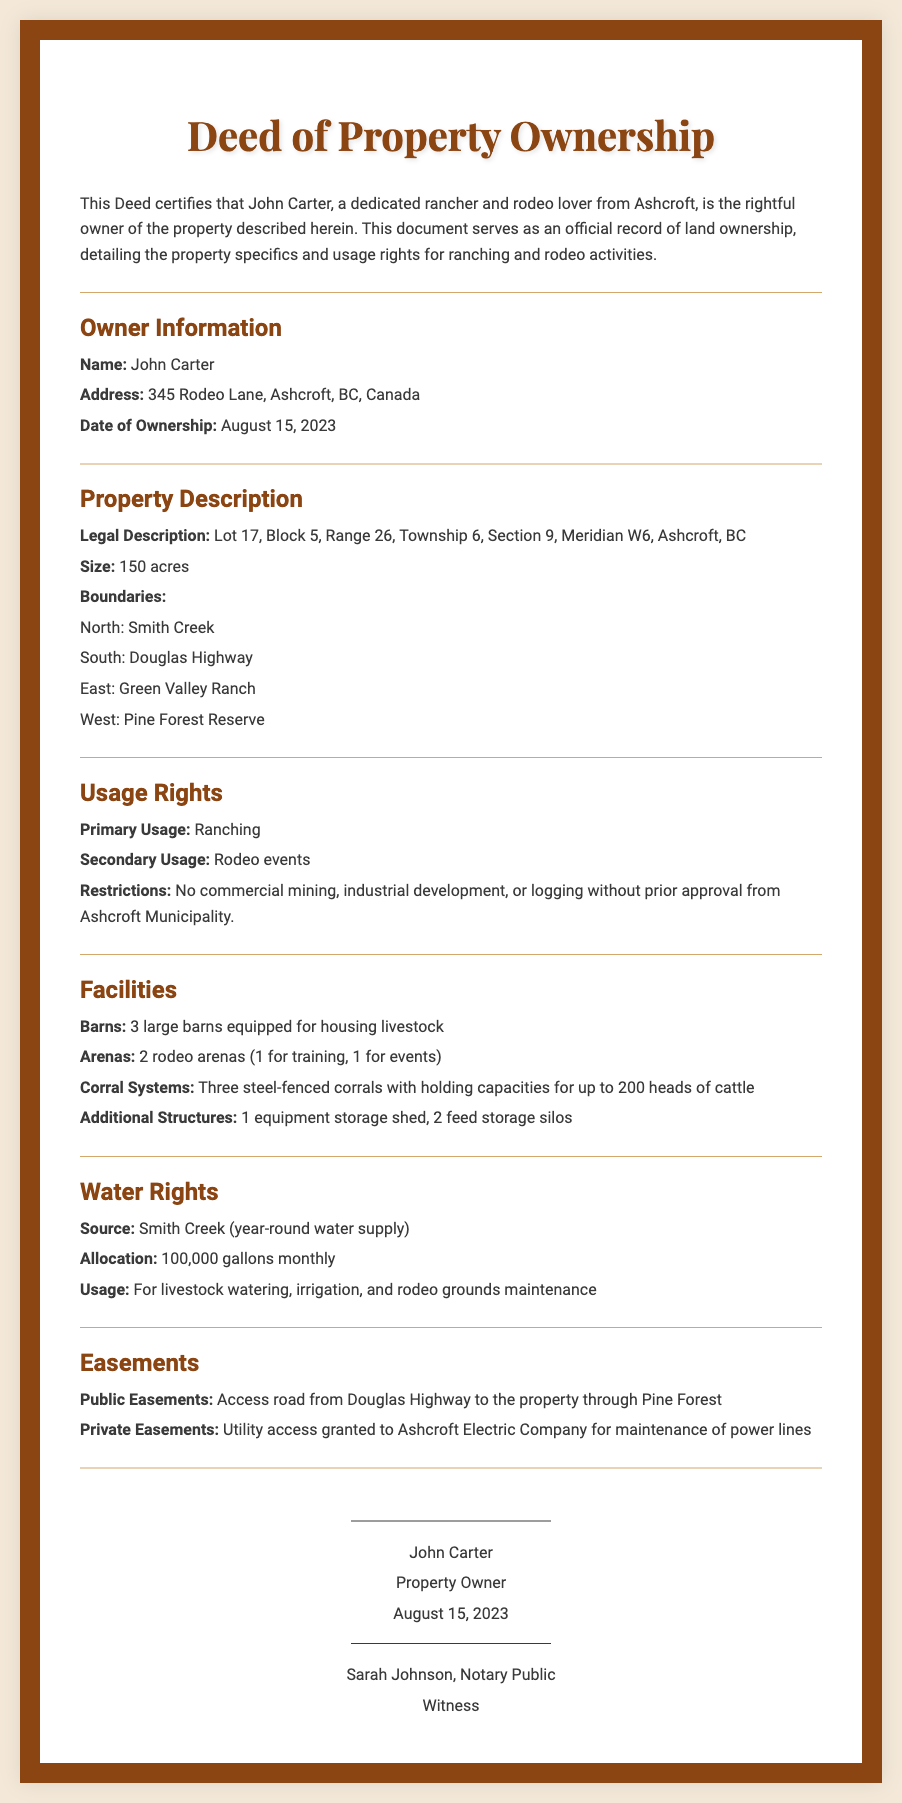What is the name of the property owner? The name of the property owner is stated in the Owner Information section of the document.
Answer: John Carter What is the address of the property owner? The address is provided in the Owner Information section.
Answer: 345 Rodeo Lane, Ashcroft, BC, Canada What is the size of the property? The size is mentioned in the Property Description section.
Answer: 150 acres What are the primary and secondary usages of the property? The usages are detailed in the Usage Rights section.
Answer: Ranching; Rodeo events How many barns are mentioned in the Facilities section? The number of barns is directly provided in the Facilities description.
Answer: 3 Who is the witness to the deed? The witness is identified in the signature section of the document.
Answer: Sarah Johnson, Notary Public What is the monthly water allocation for the property? The allocation is specified in the Water Rights section of the document.
Answer: 100,000 gallons What is the south boundary of the property? The south boundary is listed in the Property Description section.
Answer: Douglas Highway What is one restriction placed on the property? Restrictions are outlined in the Usage Rights section.
Answer: No commercial mining, industrial development, or logging without prior approval What is the legal description of the property? The legal description can be found in the Property Description section of the document.
Answer: Lot 17, Block 5, Range 26, Township 6, Section 9, Meridian W6, Ashcroft, BC 